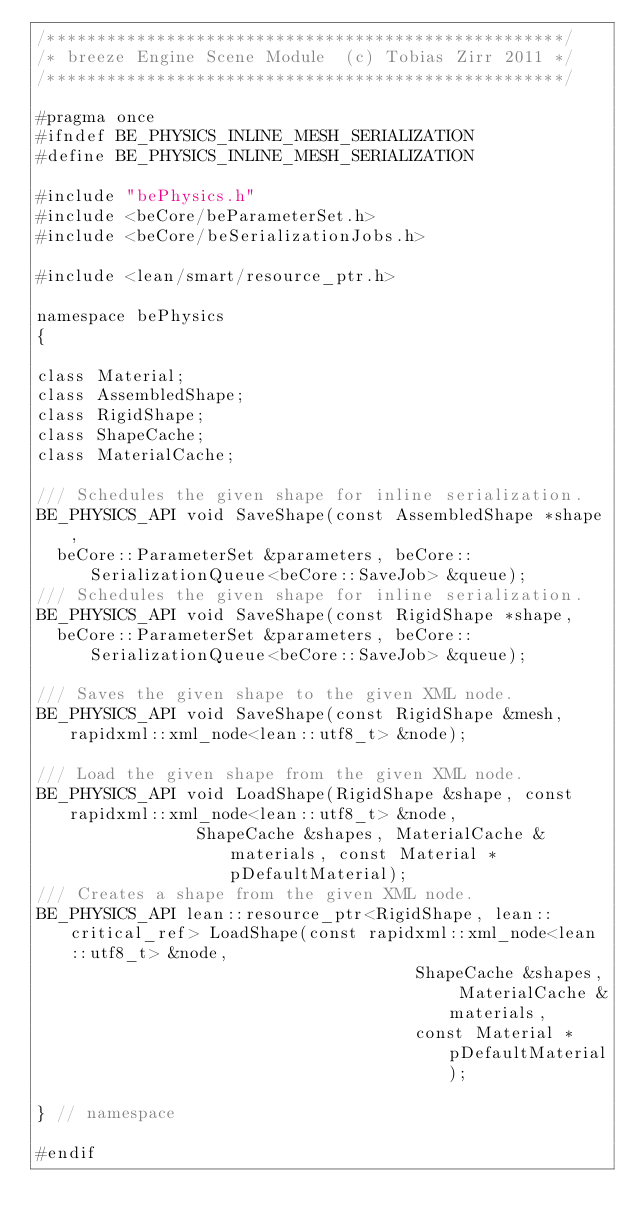<code> <loc_0><loc_0><loc_500><loc_500><_C_>/****************************************************/
/* breeze Engine Scene Module  (c) Tobias Zirr 2011 */
/****************************************************/

#pragma once
#ifndef BE_PHYSICS_INLINE_MESH_SERIALIZATION
#define BE_PHYSICS_INLINE_MESH_SERIALIZATION

#include "bePhysics.h"
#include <beCore/beParameterSet.h>
#include <beCore/beSerializationJobs.h>

#include <lean/smart/resource_ptr.h>

namespace bePhysics
{

class Material;
class AssembledShape;
class RigidShape;
class ShapeCache;
class MaterialCache;

/// Schedules the given shape for inline serialization.
BE_PHYSICS_API void SaveShape(const AssembledShape *shape,
	beCore::ParameterSet &parameters, beCore::SerializationQueue<beCore::SaveJob> &queue);
/// Schedules the given shape for inline serialization.
BE_PHYSICS_API void SaveShape(const RigidShape *shape,
	beCore::ParameterSet &parameters, beCore::SerializationQueue<beCore::SaveJob> &queue);

/// Saves the given shape to the given XML node.
BE_PHYSICS_API void SaveShape(const RigidShape &mesh, rapidxml::xml_node<lean::utf8_t> &node);

/// Load the given shape from the given XML node.
BE_PHYSICS_API void LoadShape(RigidShape &shape, const rapidxml::xml_node<lean::utf8_t> &node,
							  ShapeCache &shapes, MaterialCache &materials, const Material *pDefaultMaterial);
/// Creates a shape from the given XML node.
BE_PHYSICS_API lean::resource_ptr<RigidShape, lean::critical_ref> LoadShape(const rapidxml::xml_node<lean::utf8_t> &node,
																			ShapeCache &shapes, MaterialCache &materials,
																			const Material *pDefaultMaterial);

} // namespace

#endif
</code> 